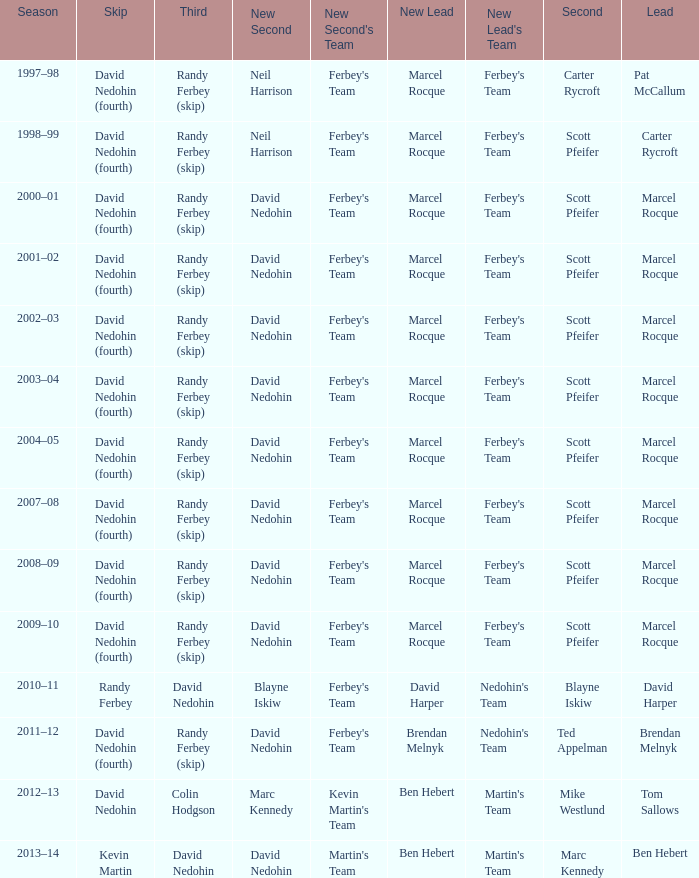Which Second has a Lead of ben hebert? Marc Kennedy. 